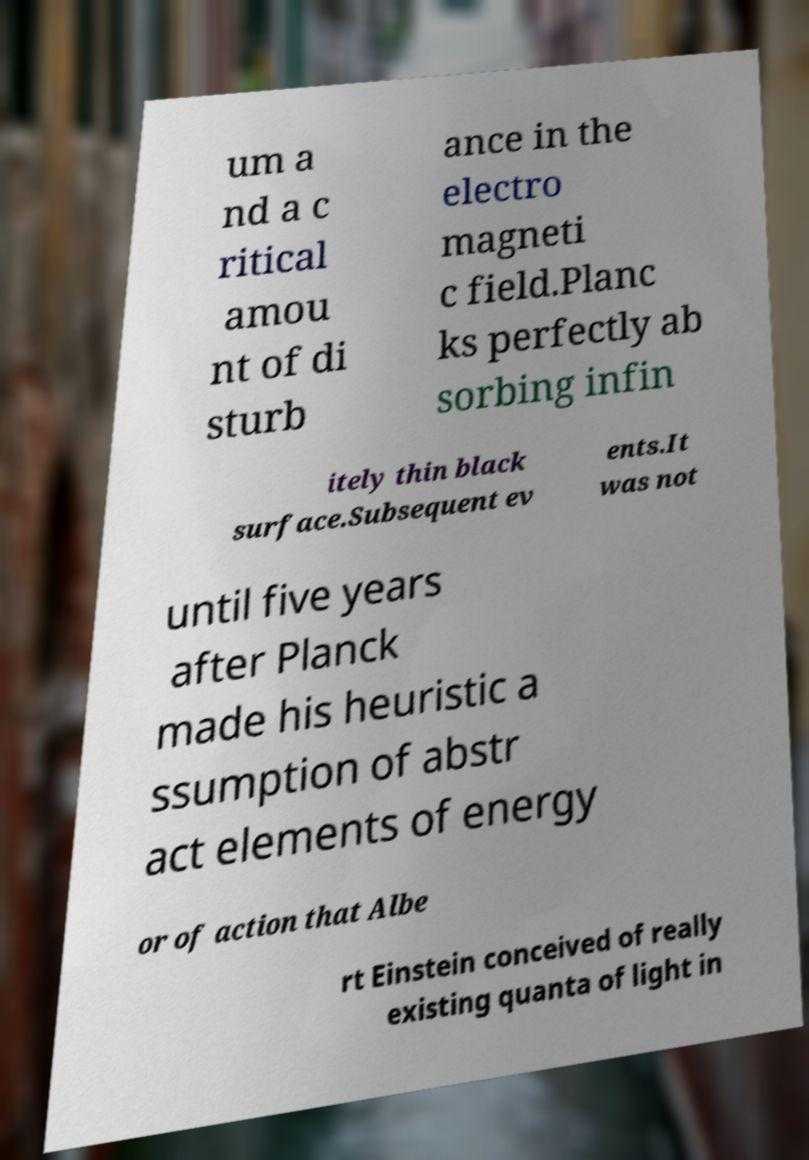Please identify and transcribe the text found in this image. um a nd a c ritical amou nt of di sturb ance in the electro magneti c field.Planc ks perfectly ab sorbing infin itely thin black surface.Subsequent ev ents.It was not until five years after Planck made his heuristic a ssumption of abstr act elements of energy or of action that Albe rt Einstein conceived of really existing quanta of light in 